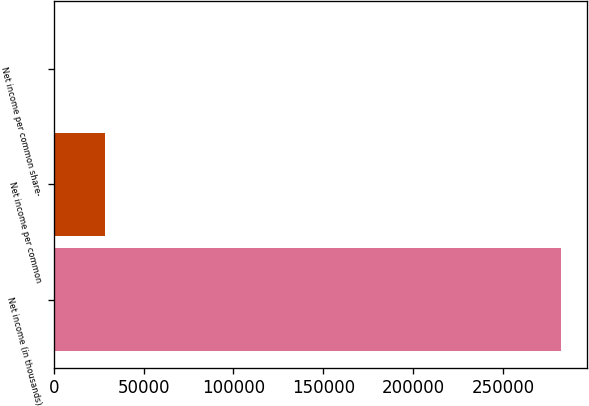Convert chart to OTSL. <chart><loc_0><loc_0><loc_500><loc_500><bar_chart><fcel>Net income (in thousands)<fcel>Net income per common<fcel>Net income per common share-<nl><fcel>282460<fcel>28248.3<fcel>2.6<nl></chart> 